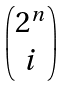<formula> <loc_0><loc_0><loc_500><loc_500>\begin{pmatrix} 2 ^ { n } \\ i \end{pmatrix}</formula> 